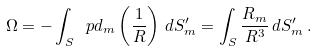Convert formula to latex. <formula><loc_0><loc_0><loc_500><loc_500>\Omega = - \int _ { S } \ p d _ { m } \left ( \frac { 1 } { R } \right ) \, d S ^ { \prime } _ { m } = \int _ { S } \frac { R _ { m } } { R ^ { 3 } } \, d S ^ { \prime } _ { m } \, .</formula> 